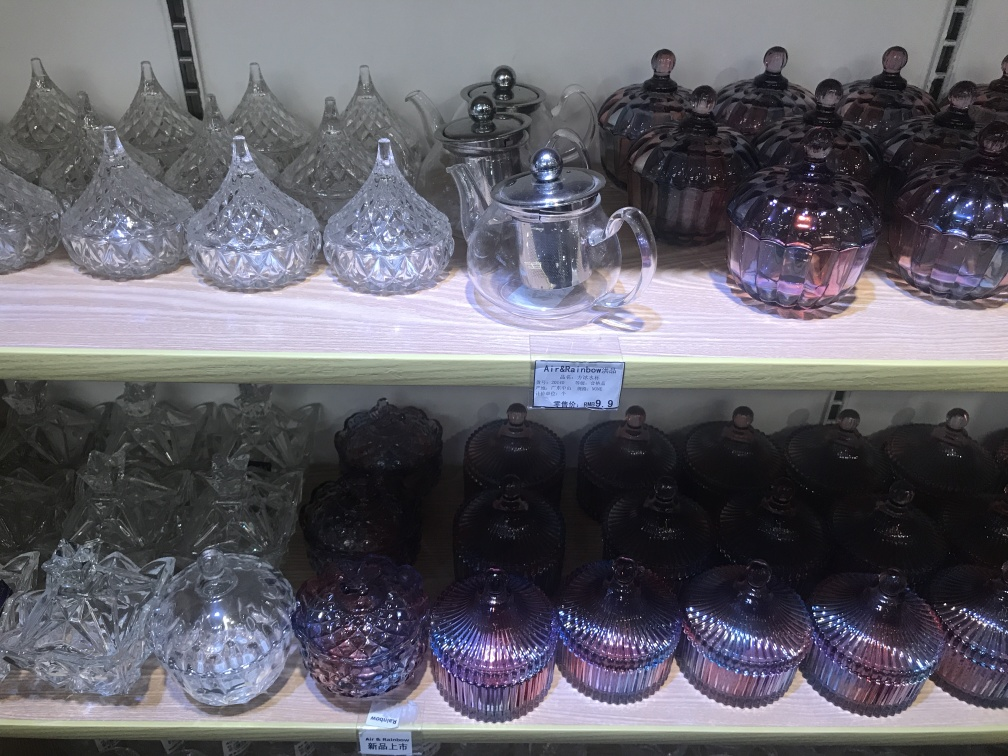Could you suggest an occasion where these glass pieces might be used? These glass items are versatile and could be used on various occasions. The clear ones are perfect for formal gatherings or traditional tea ceremonies, exuding elegance. The colored pieces may suit more casual or celebratory events, potentially being used to serve refreshments or as part of a festive table setting. 